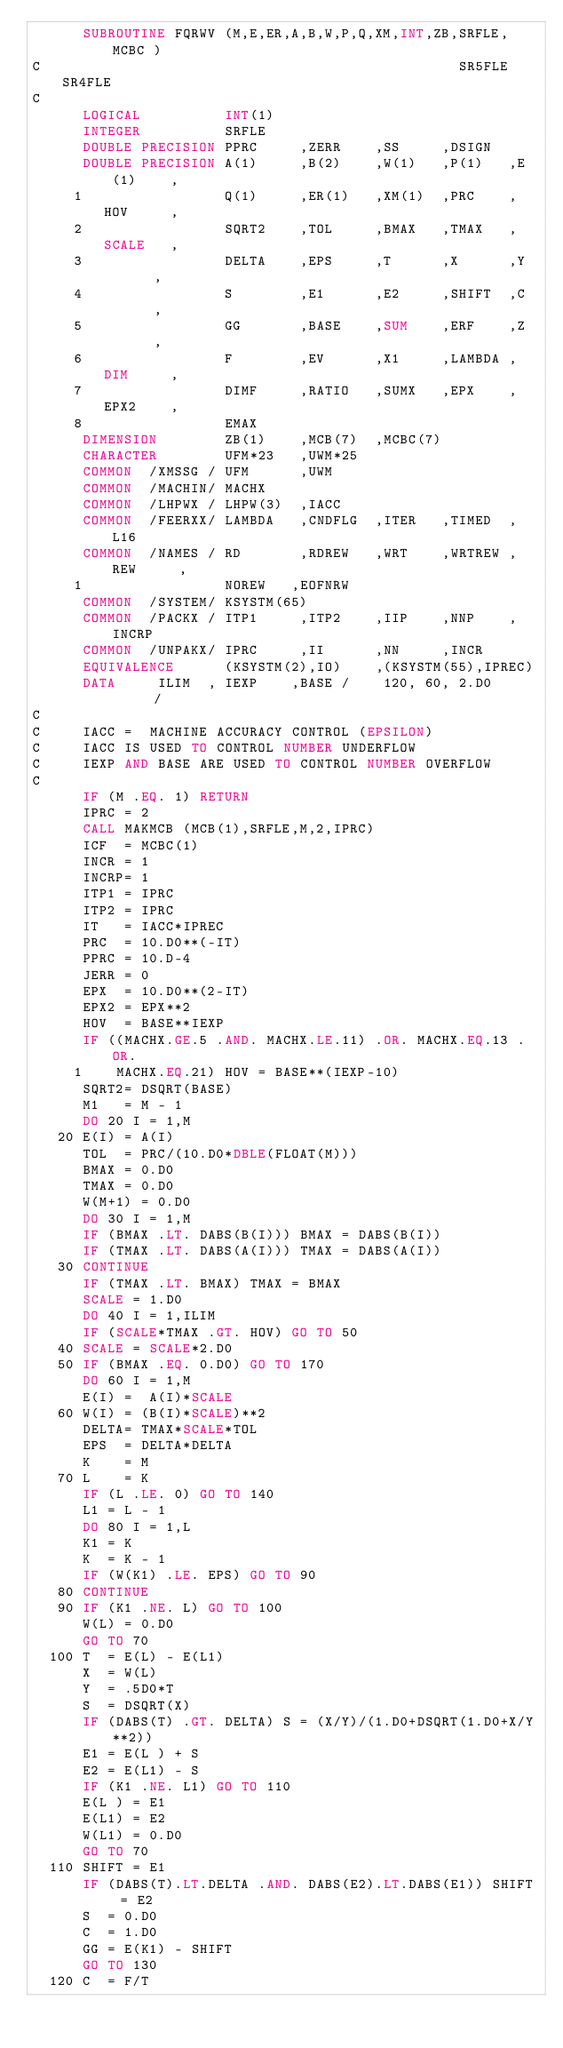<code> <loc_0><loc_0><loc_500><loc_500><_FORTRAN_>      SUBROUTINE FQRWV (M,E,ER,A,B,W,P,Q,XM,INT,ZB,SRFLE, MCBC )
C                                                  SR5FLE SR4FLE
C
      LOGICAL          INT(1)
      INTEGER          SRFLE
      DOUBLE PRECISION PPRC     ,ZERR    ,SS     ,DSIGN
      DOUBLE PRECISION A(1)     ,B(2)    ,W(1)   ,P(1)   ,E(1)    ,
     1                 Q(1)     ,ER(1)   ,XM(1)  ,PRC    ,HOV     ,
     2                 SQRT2    ,TOL     ,BMAX   ,TMAX   ,SCALE   ,
     3                 DELTA    ,EPS     ,T      ,X      ,Y       ,
     4                 S        ,E1      ,E2     ,SHIFT  ,C       ,
     5                 GG       ,BASE    ,SUM    ,ERF    ,Z       ,
     6                 F        ,EV      ,X1     ,LAMBDA ,DIM     ,
     7                 DIMF     ,RATIO   ,SUMX   ,EPX    ,EPX2    ,
     8                 EMAX
      DIMENSION        ZB(1)    ,MCB(7)  ,MCBC(7)
      CHARACTER        UFM*23   ,UWM*25
      COMMON  /XMSSG / UFM      ,UWM
      COMMON  /MACHIN/ MACHX
      COMMON  /LHPWX / LHPW(3)  ,IACC
      COMMON  /FEERXX/ LAMBDA   ,CNDFLG  ,ITER   ,TIMED  ,L16
      COMMON  /NAMES / RD       ,RDREW   ,WRT    ,WRTREW ,REW     ,
     1                 NOREW   ,EOFNRW
      COMMON  /SYSTEM/ KSYSTM(65)
      COMMON  /PACKX / ITP1     ,ITP2    ,IIP    ,NNP    ,INCRP
      COMMON  /UNPAKX/ IPRC     ,II      ,NN     ,INCR
      EQUIVALENCE      (KSYSTM(2),IO)    ,(KSYSTM(55),IPREC)
      DATA     ILIM  , IEXP    ,BASE /    120, 60, 2.D0      /
C
C     IACC =  MACHINE ACCURACY CONTROL (EPSILON)
C     IACC IS USED TO CONTROL NUMBER UNDERFLOW
C     IEXP AND BASE ARE USED TO CONTROL NUMBER OVERFLOW
C
      IF (M .EQ. 1) RETURN
      IPRC = 2
      CALL MAKMCB (MCB(1),SRFLE,M,2,IPRC)
      ICF  = MCBC(1)
      INCR = 1
      INCRP= 1
      ITP1 = IPRC
      ITP2 = IPRC
      IT   = IACC*IPREC
      PRC  = 10.D0**(-IT)
      PPRC = 10.D-4
      JERR = 0
      EPX  = 10.D0**(2-IT)
      EPX2 = EPX**2
      HOV  = BASE**IEXP
      IF ((MACHX.GE.5 .AND. MACHX.LE.11) .OR. MACHX.EQ.13 .OR.
     1    MACHX.EQ.21) HOV = BASE**(IEXP-10)
      SQRT2= DSQRT(BASE)
      M1   = M - 1
      DO 20 I = 1,M
   20 E(I) = A(I)
      TOL  = PRC/(10.D0*DBLE(FLOAT(M)))
      BMAX = 0.D0
      TMAX = 0.D0
      W(M+1) = 0.D0
      DO 30 I = 1,M
      IF (BMAX .LT. DABS(B(I))) BMAX = DABS(B(I))
      IF (TMAX .LT. DABS(A(I))) TMAX = DABS(A(I))
   30 CONTINUE
      IF (TMAX .LT. BMAX) TMAX = BMAX
      SCALE = 1.D0
      DO 40 I = 1,ILIM
      IF (SCALE*TMAX .GT. HOV) GO TO 50
   40 SCALE = SCALE*2.D0
   50 IF (BMAX .EQ. 0.D0) GO TO 170
      DO 60 I = 1,M
      E(I) =  A(I)*SCALE
   60 W(I) = (B(I)*SCALE)**2
      DELTA= TMAX*SCALE*TOL
      EPS  = DELTA*DELTA
      K    = M
   70 L    = K
      IF (L .LE. 0) GO TO 140
      L1 = L - 1
      DO 80 I = 1,L
      K1 = K
      K  = K - 1
      IF (W(K1) .LE. EPS) GO TO 90
   80 CONTINUE
   90 IF (K1 .NE. L) GO TO 100
      W(L) = 0.D0
      GO TO 70
  100 T  = E(L) - E(L1)
      X  = W(L)
      Y  = .5D0*T
      S  = DSQRT(X)
      IF (DABS(T) .GT. DELTA) S = (X/Y)/(1.D0+DSQRT(1.D0+X/Y**2))
      E1 = E(L ) + S
      E2 = E(L1) - S
      IF (K1 .NE. L1) GO TO 110
      E(L ) = E1
      E(L1) = E2
      W(L1) = 0.D0
      GO TO 70
  110 SHIFT = E1
      IF (DABS(T).LT.DELTA .AND. DABS(E2).LT.DABS(E1)) SHIFT = E2
      S  = 0.D0
      C  = 1.D0
      GG = E(K1) - SHIFT
      GO TO 130
  120 C  = F/T</code> 